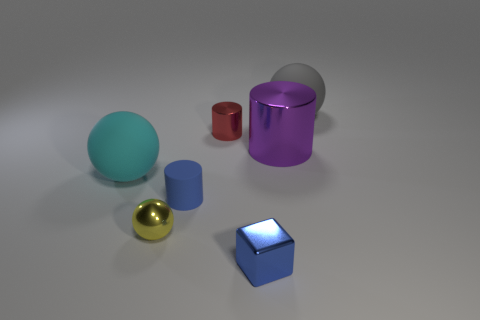Add 1 yellow spheres. How many objects exist? 8 Subtract all spheres. How many objects are left? 4 Subtract all large matte cylinders. Subtract all gray things. How many objects are left? 6 Add 1 red objects. How many red objects are left? 2 Add 4 tiny yellow things. How many tiny yellow things exist? 5 Subtract 1 cyan spheres. How many objects are left? 6 